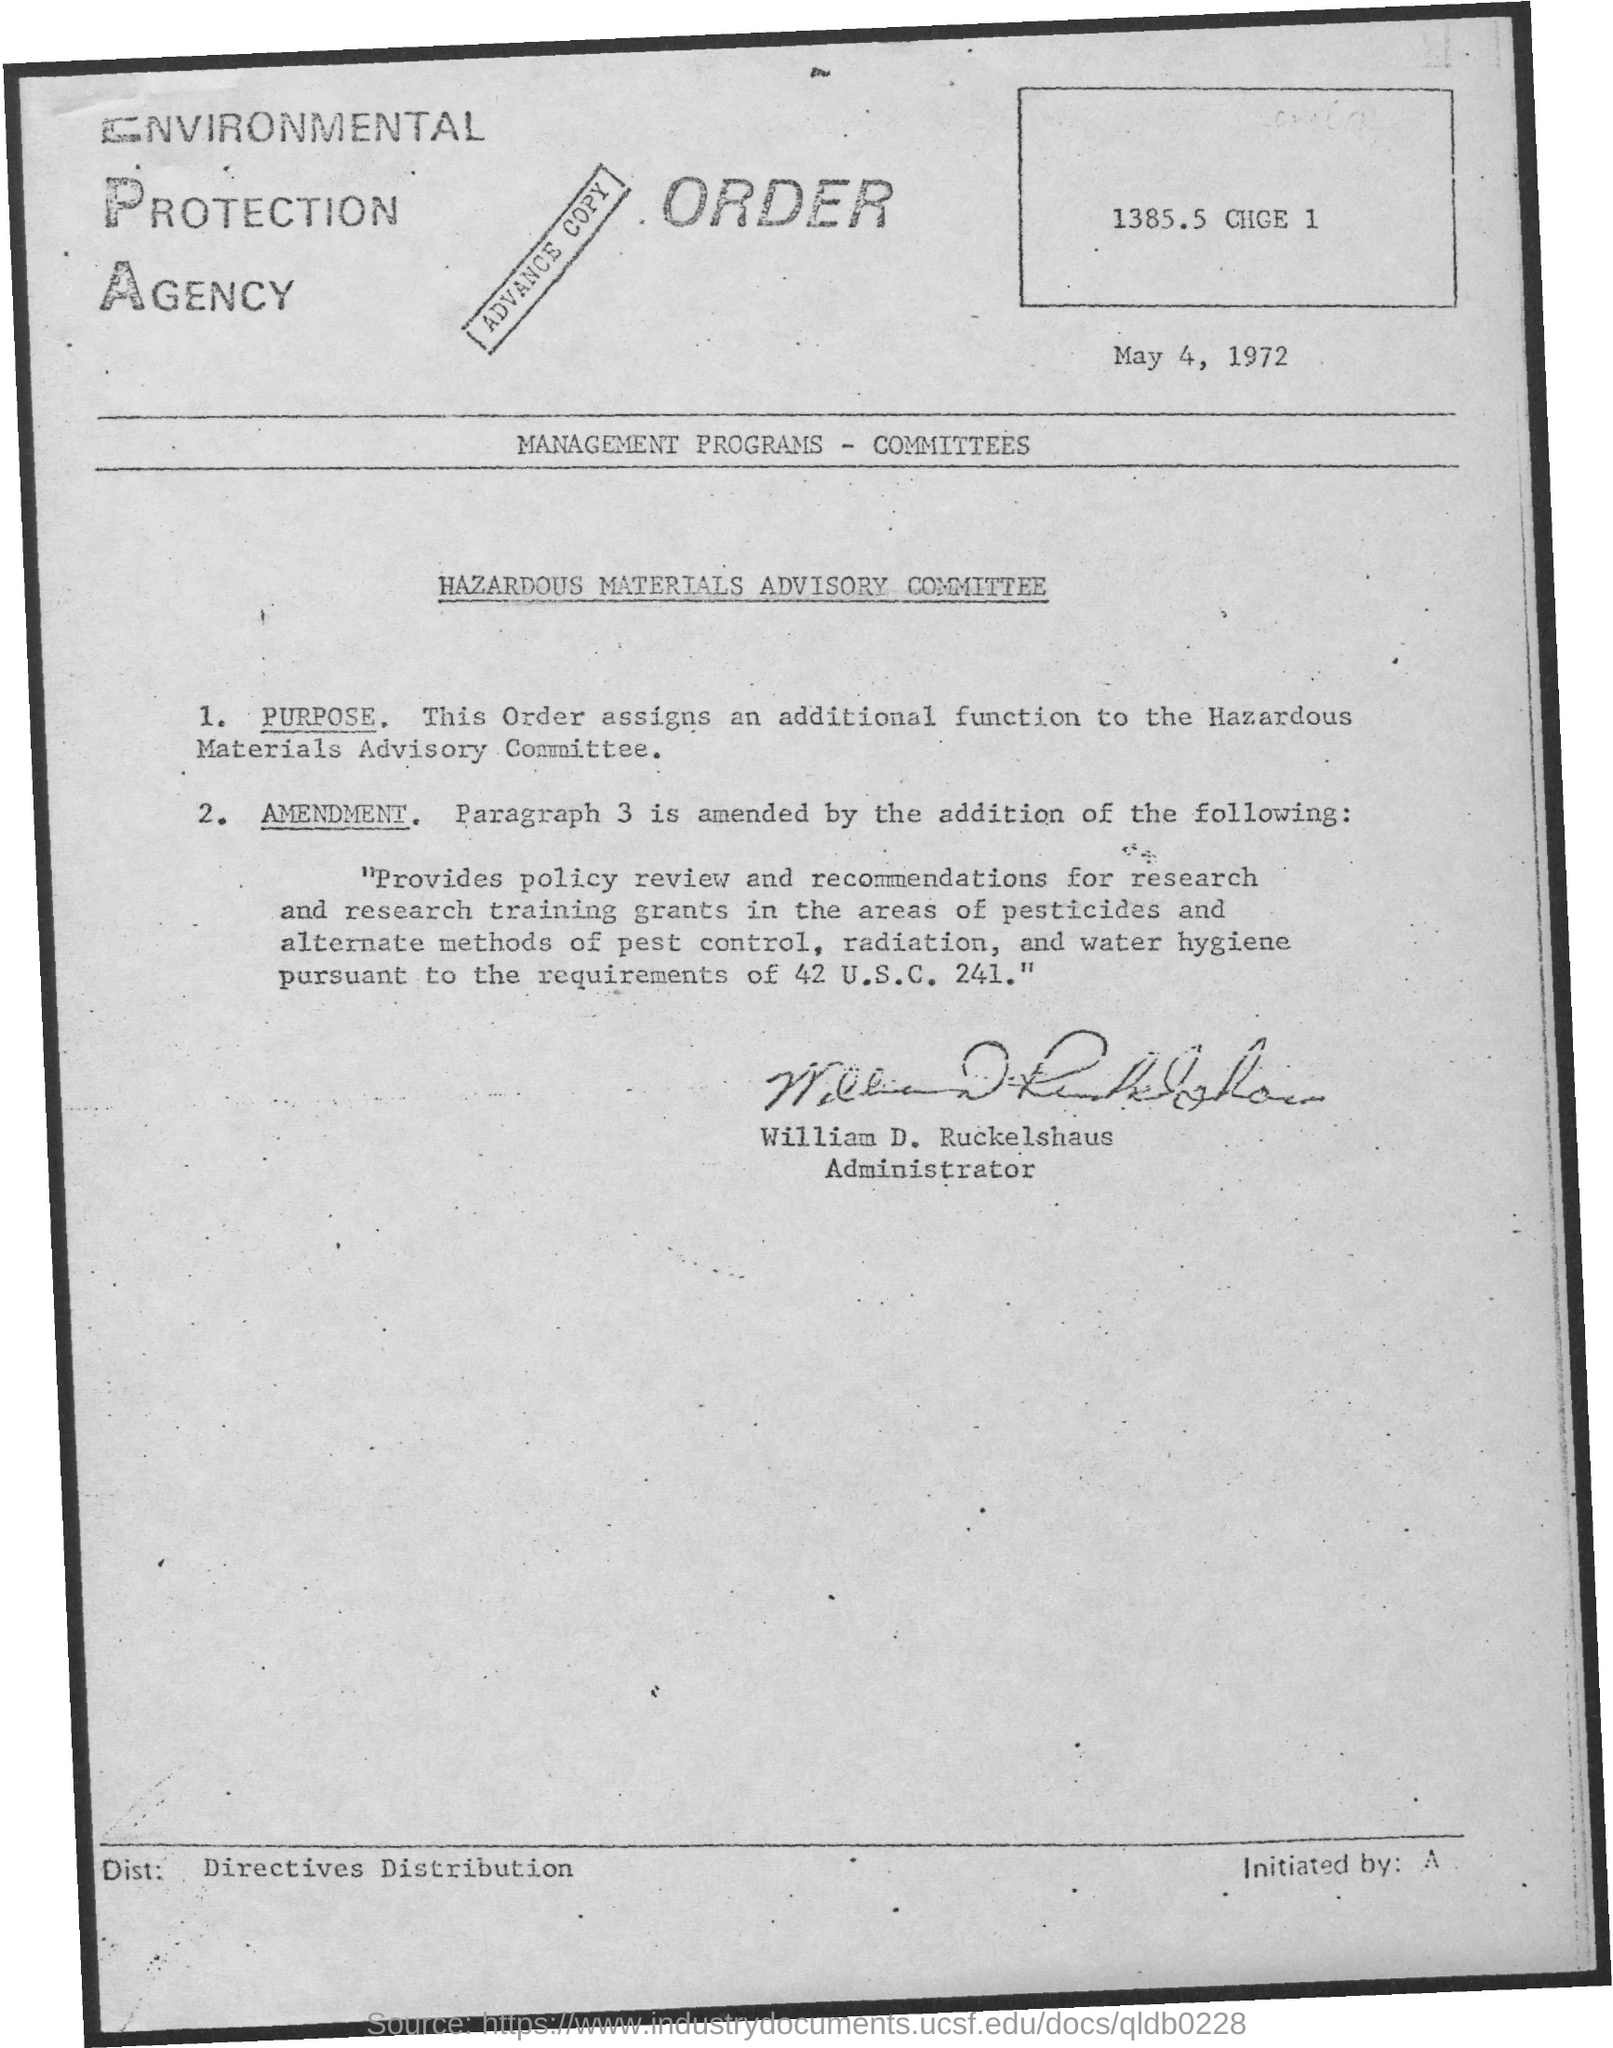Outline some significant characteristics in this image. The date on the document is May 4, 1972. William D. Ruckelshaus is the administrator. 